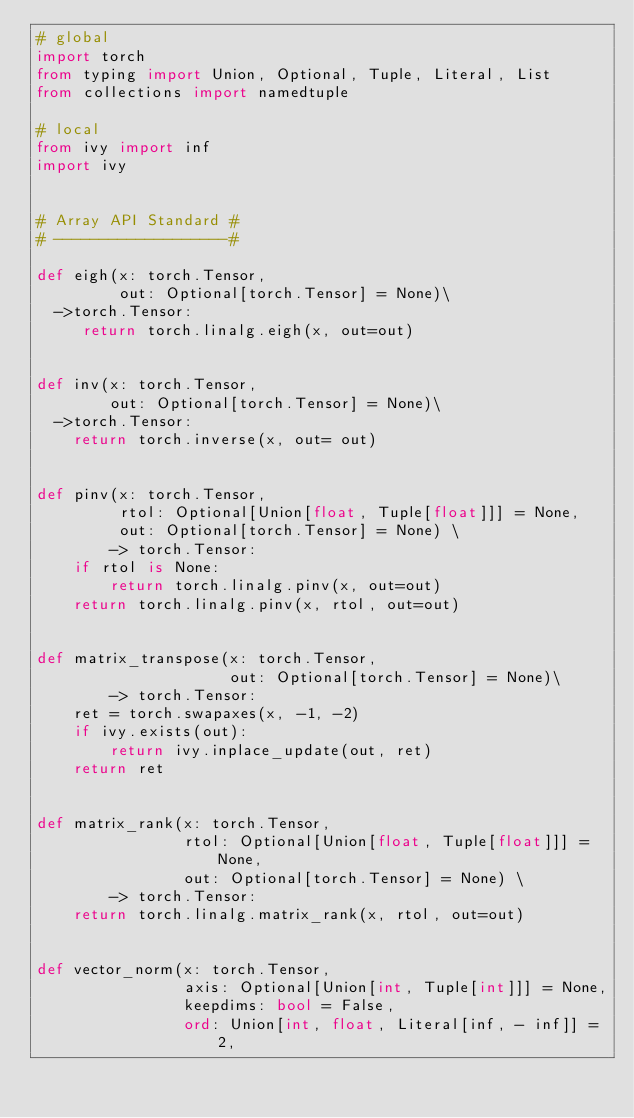<code> <loc_0><loc_0><loc_500><loc_500><_Python_># global
import torch
from typing import Union, Optional, Tuple, Literal, List
from collections import namedtuple

# local
from ivy import inf
import ivy


# Array API Standard #
# -------------------#

def eigh(x: torch.Tensor,
         out: Optional[torch.Tensor] = None)\
  ->torch.Tensor:
     return torch.linalg.eigh(x, out=out)


def inv(x: torch.Tensor,
        out: Optional[torch.Tensor] = None)\
  ->torch.Tensor:
    return torch.inverse(x, out= out)


def pinv(x: torch.Tensor,
         rtol: Optional[Union[float, Tuple[float]]] = None,
         out: Optional[torch.Tensor] = None) \
        -> torch.Tensor:
    if rtol is None:
        return torch.linalg.pinv(x, out=out)
    return torch.linalg.pinv(x, rtol, out=out)


def matrix_transpose(x: torch.Tensor,
                     out: Optional[torch.Tensor] = None)\
        -> torch.Tensor:
    ret = torch.swapaxes(x, -1, -2)
    if ivy.exists(out):
        return ivy.inplace_update(out, ret)
    return ret


def matrix_rank(x: torch.Tensor,
                rtol: Optional[Union[float, Tuple[float]]] = None,
                out: Optional[torch.Tensor] = None) \
        -> torch.Tensor:
    return torch.linalg.matrix_rank(x, rtol, out=out)


def vector_norm(x: torch.Tensor,
                axis: Optional[Union[int, Tuple[int]]] = None,
                keepdims: bool = False,
                ord: Union[int, float, Literal[inf, - inf]] = 2,</code> 